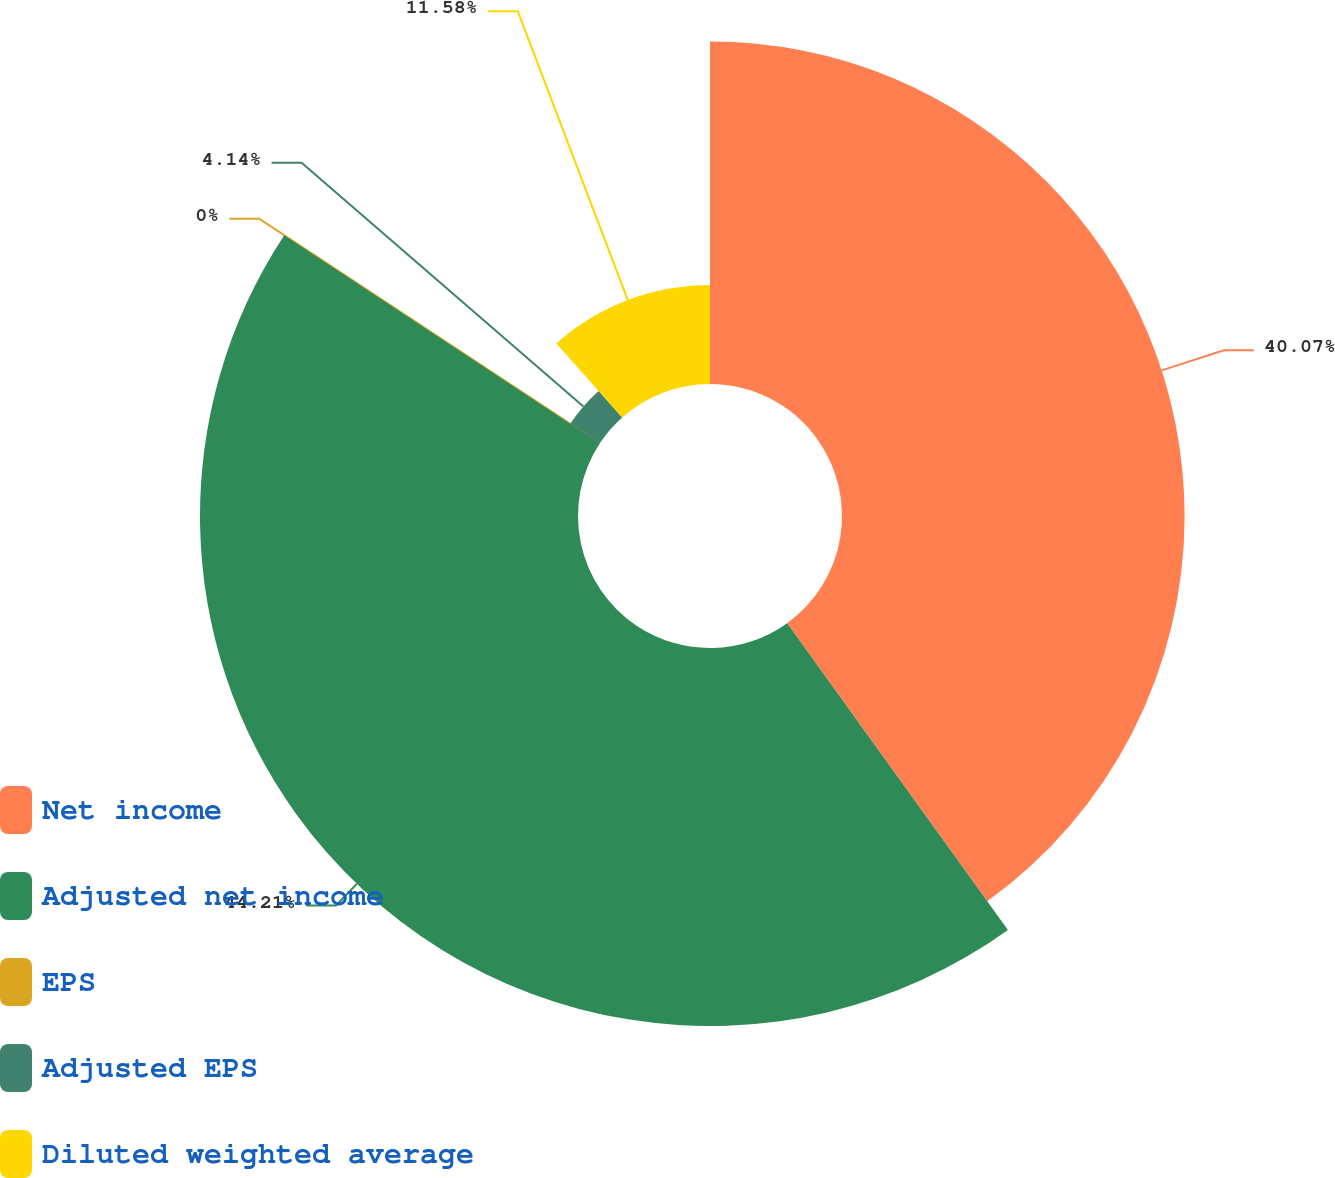<chart> <loc_0><loc_0><loc_500><loc_500><pie_chart><fcel>Net income<fcel>Adjusted net income<fcel>EPS<fcel>Adjusted EPS<fcel>Diluted weighted average<nl><fcel>40.07%<fcel>44.21%<fcel>0.0%<fcel>4.14%<fcel>11.58%<nl></chart> 